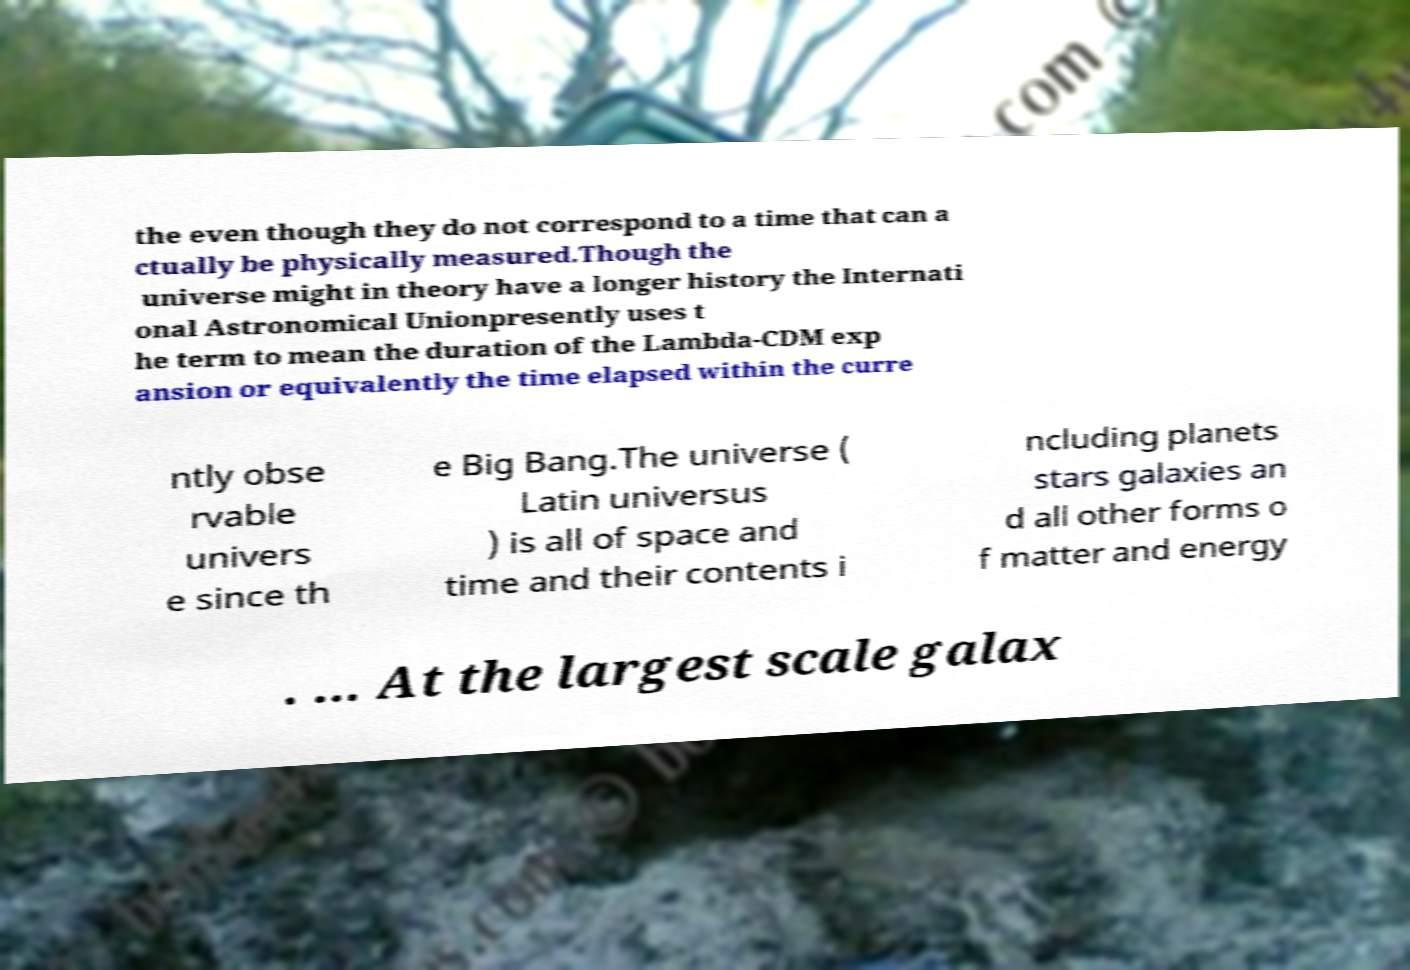What messages or text are displayed in this image? I need them in a readable, typed format. the even though they do not correspond to a time that can a ctually be physically measured.Though the universe might in theory have a longer history the Internati onal Astronomical Unionpresently uses t he term to mean the duration of the Lambda-CDM exp ansion or equivalently the time elapsed within the curre ntly obse rvable univers e since th e Big Bang.The universe ( Latin universus ) is all of space and time and their contents i ncluding planets stars galaxies an d all other forms o f matter and energy . ... At the largest scale galax 